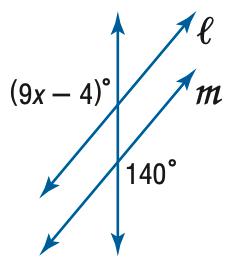Question: Find x so that m \parallel n.
Choices:
A. 13
B. 14
C. 15
D. 16
Answer with the letter. Answer: D 